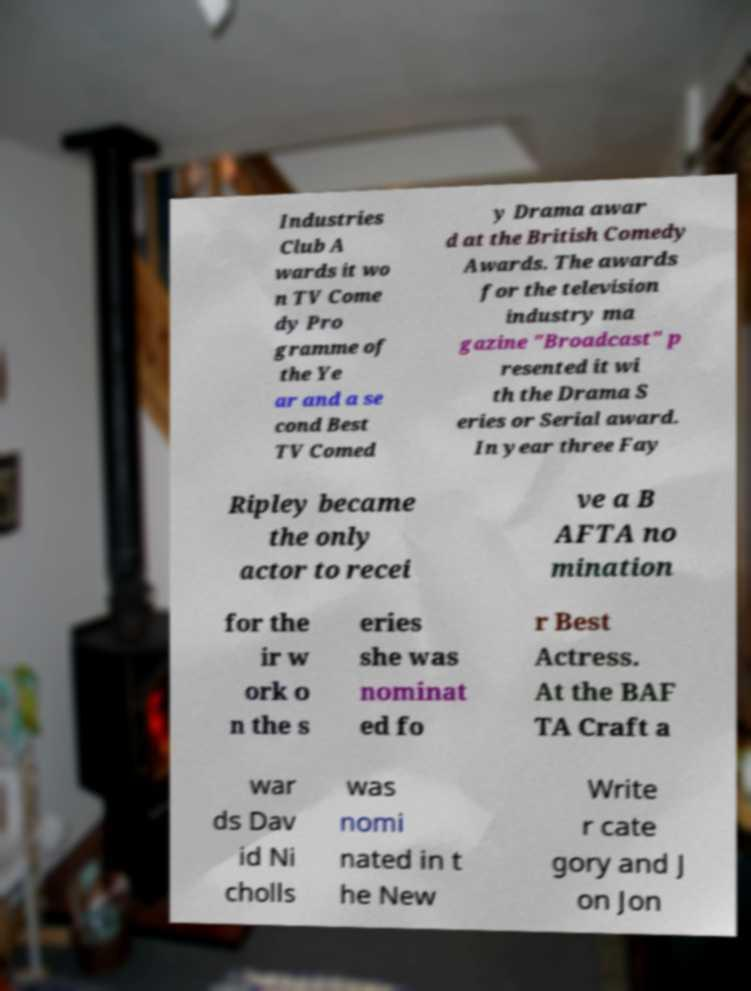Can you accurately transcribe the text from the provided image for me? Industries Club A wards it wo n TV Come dy Pro gramme of the Ye ar and a se cond Best TV Comed y Drama awar d at the British Comedy Awards. The awards for the television industry ma gazine "Broadcast" p resented it wi th the Drama S eries or Serial award. In year three Fay Ripley became the only actor to recei ve a B AFTA no mination for the ir w ork o n the s eries she was nominat ed fo r Best Actress. At the BAF TA Craft a war ds Dav id Ni cholls was nomi nated in t he New Write r cate gory and J on Jon 